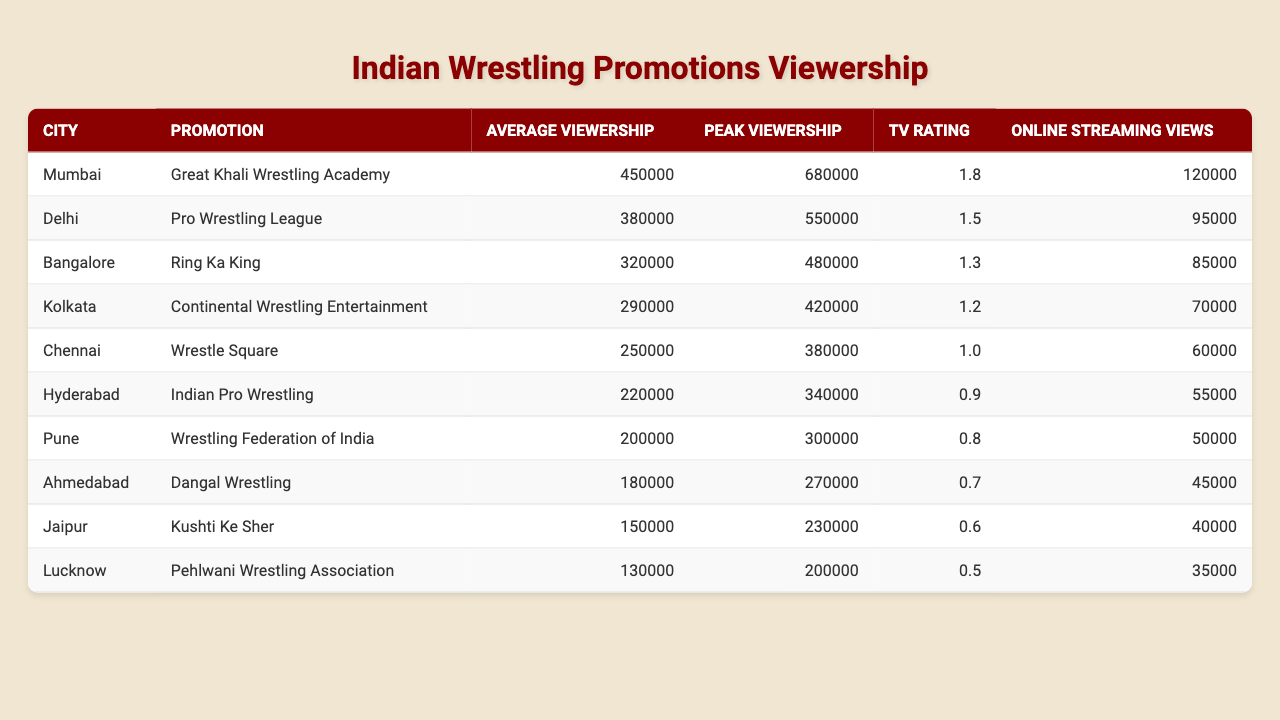What is the average viewership for the Great Khali Wrestling Academy in Mumbai? The table lists the average viewership for the Great Khali Wrestling Academy in Mumbai as 450,000.
Answer: 450000 Which city has the highest peak viewership? By examining the table, Mumbai has the highest peak viewership listed as 680,000, compared to other cities.
Answer: Mumbai What is the total online streaming views for all promotions listed? We need to sum the online streaming views for each promotion: 120,000 + 95,000 + 85,000 + 70,000 + 60,000 + 55,000 + 50,000 + 45,000 + 40,000 + 35,000 =  755,000.
Answer: 755000 Is the TV rating for the Ring Ka King promotion higher than 1.0? The TV rating for Ring Ka King is 1.3, which is indeed higher than 1.0.
Answer: Yes Which promotion has the lowest average viewership, and what is that number? The promotion with the lowest average viewership is the Pehlwani Wrestling Association from Lucknow, with an average of 130,000 viewers.
Answer: Pehlwani Wrestling Association, 130000 If we compare the average viewership of Kolkata and Chennai, which one is higher, and by how much? Kolkata has an average viewership of 290,000, while Chennai has 250,000. The difference is 290,000 - 250,000 = 40,000.
Answer: Kolkata is higher by 40000 Which two promotions have a combined average viewership greater than 700,000? Looking at the table, the combined average viewership for Mumbai (450,000) and Delhi (380,000) totals 830,000, which is greater than 700,000.
Answer: Mumbai and Delhi Is it true that Delhi has a TV rating above 1.5? The TV rating for Delhi's Pro Wrestling League is 1.5, which means it is not above 1.5.
Answer: No What is the average viewership difference between the top city and the bottom city? The top city, Mumbai, has an average viewership of 450,000, while the bottom city, Lucknow, has 130,000. The difference is 450,000 - 130,000 = 320,000.
Answer: 320000 How many promotions have an online streaming view count of less than 50,000? From the table, only the Ahmedabad and Jaipur promotions have less than 50,000 online streaming views, totaling 2 promotions.
Answer: 2 